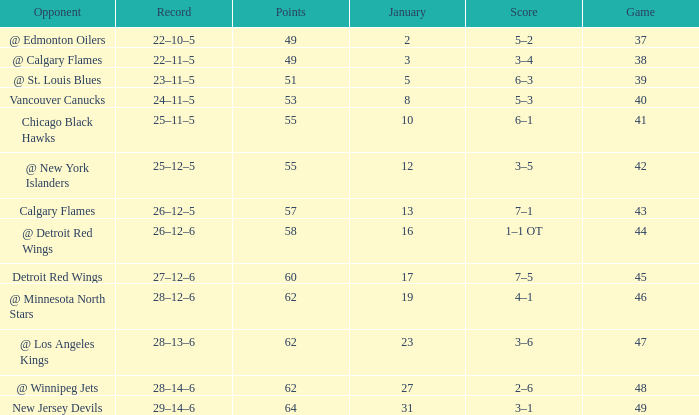How many Games have a Score of 2–6, and Points larger than 62? 0.0. 